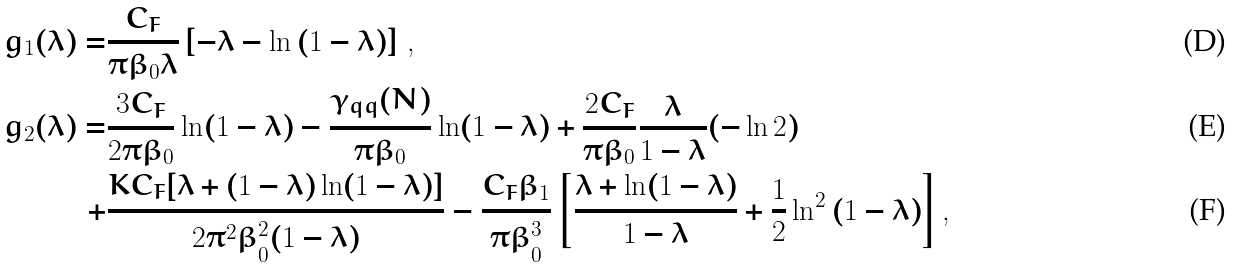<formula> <loc_0><loc_0><loc_500><loc_500>g _ { 1 } ( \lambda ) = & \frac { C _ { F } } { \pi \beta _ { 0 } \lambda } \left [ - \lambda - \ln { ( 1 - \lambda ) } \right ] \, , \\ g _ { 2 } ( { \lambda } ) = & \frac { 3 C _ { F } } { 2 \pi \beta _ { 0 } } \ln ( 1 - \lambda ) - \frac { \gamma _ { q q } ( N ) } { \pi \beta _ { 0 } } \ln ( 1 - \lambda ) + \frac { 2 C _ { F } } { \pi \beta _ { 0 } } \frac { \lambda } { 1 - \lambda } ( - \ln 2 ) \\ + & \frac { K C _ { F } [ \lambda + ( 1 - \lambda ) \ln ( 1 - \lambda ) ] } { 2 \pi ^ { 2 } \beta _ { 0 } ^ { 2 } ( 1 - \lambda ) } - \frac { C _ { F } \beta _ { 1 } } { \pi \beta _ { 0 } ^ { 3 } } \left [ \frac { \lambda + \ln ( 1 - \lambda ) } { 1 - \lambda } + \frac { 1 } { 2 } \ln ^ { 2 } { ( 1 - \lambda ) } \right ] ,</formula> 